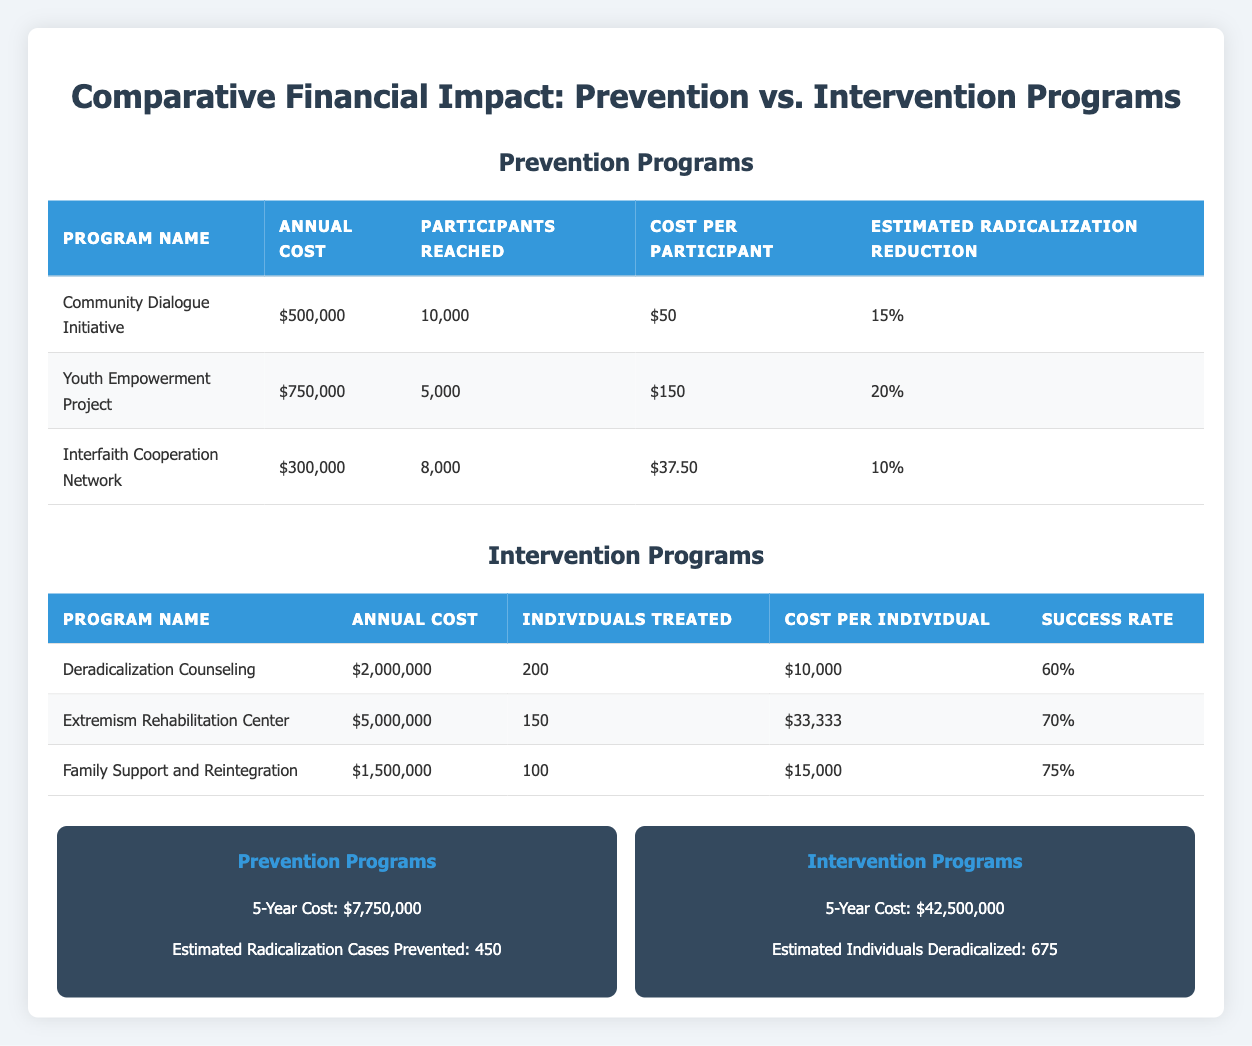What is the annual cost of the Youth Empowerment Project? The annual cost is directly listed in the table under the "Annual Cost" column for the "Youth Empowerment Project" row. The value provided is $750,000.
Answer: $750,000 Which prevention program has the lowest cost per participant? The cost per participant is listed for each prevention program. The Community Dialogue Initiative has a cost per participant of $50, while the Interfaith Cooperation Network has $37.5, which is lower than the others.
Answer: Interfaith Cooperation Network What is the total estimated radicalization reduction from all prevention programs listed? The estimated radicalization reduction for each program is given as a percentage. Summing these percentages: 15% + 20% + 10% = 45%. Therefore, the total estimated radicalization reduction is 45%.
Answer: 45% Is the success rate of the Extremism Rehabilitation Center higher than that of the Deradicalization Counseling? The success rates are specified in the table. The Extremism Rehabilitation Center has a success rate of 70% while the Deradicalization Counseling has a success rate of 60%. Since 70% is greater than 60%, the statement is true.
Answer: Yes What is the average cost per individual for the three intervention programs? The cost per individual for the three intervention programs is $10,000, $33,333, and $15,000, respectively. To find the average, sum these values (10,000 + 33,333 + 15,000 = 58,333) and divide by 3. This results in an average cost of 58,333 / 3 = about $19,444.33.
Answer: $19,444.33 Which prevention program has the highest annual cost and what is that amount? The annual costs of the prevention programs are $500,000, $750,000, and $300,000. The highest among them is $750,000 from the Youth Empowerment Project.
Answer: $750,000 What is the total 5-year cost for all prevention programs? The table shows the total 5-year cost for prevention programs is $7,750,000, which is directly mentioned. Hence, we can directly state that.
Answer: $7,750,000 Are there more individuals treated by intervention programs than participants reached in prevention programs combined? The total participants reached for prevention is 10,000 + 5,000 + 8,000 = 23,000. The total individuals treated by intervention programs is 200 + 150 + 100 = 450. Since 23,000 is greater than 450, the statement is true.
Answer: Yes 